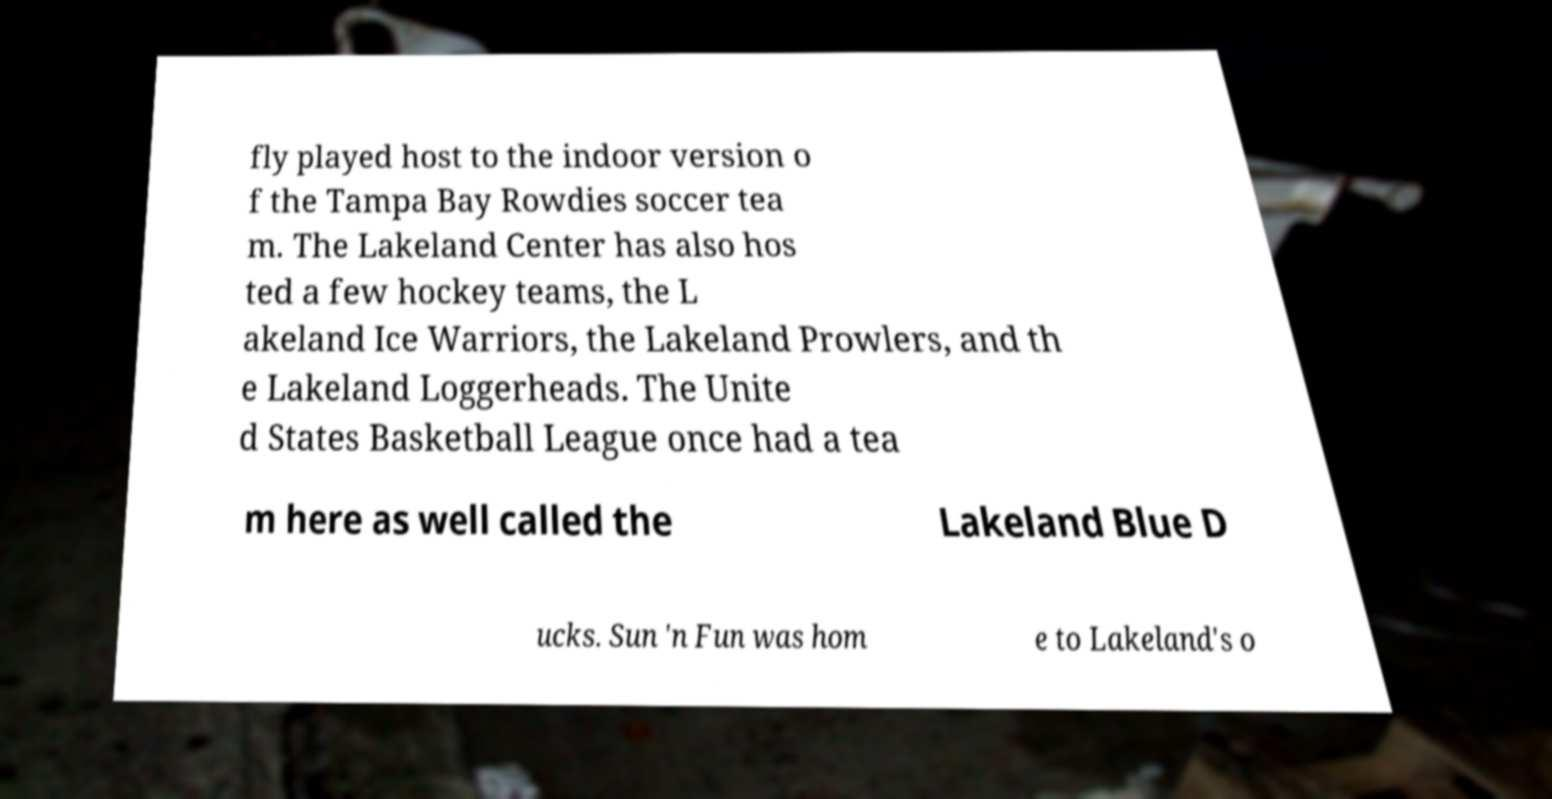I need the written content from this picture converted into text. Can you do that? fly played host to the indoor version o f the Tampa Bay Rowdies soccer tea m. The Lakeland Center has also hos ted a few hockey teams, the L akeland Ice Warriors, the Lakeland Prowlers, and th e Lakeland Loggerheads. The Unite d States Basketball League once had a tea m here as well called the Lakeland Blue D ucks. Sun 'n Fun was hom e to Lakeland's o 